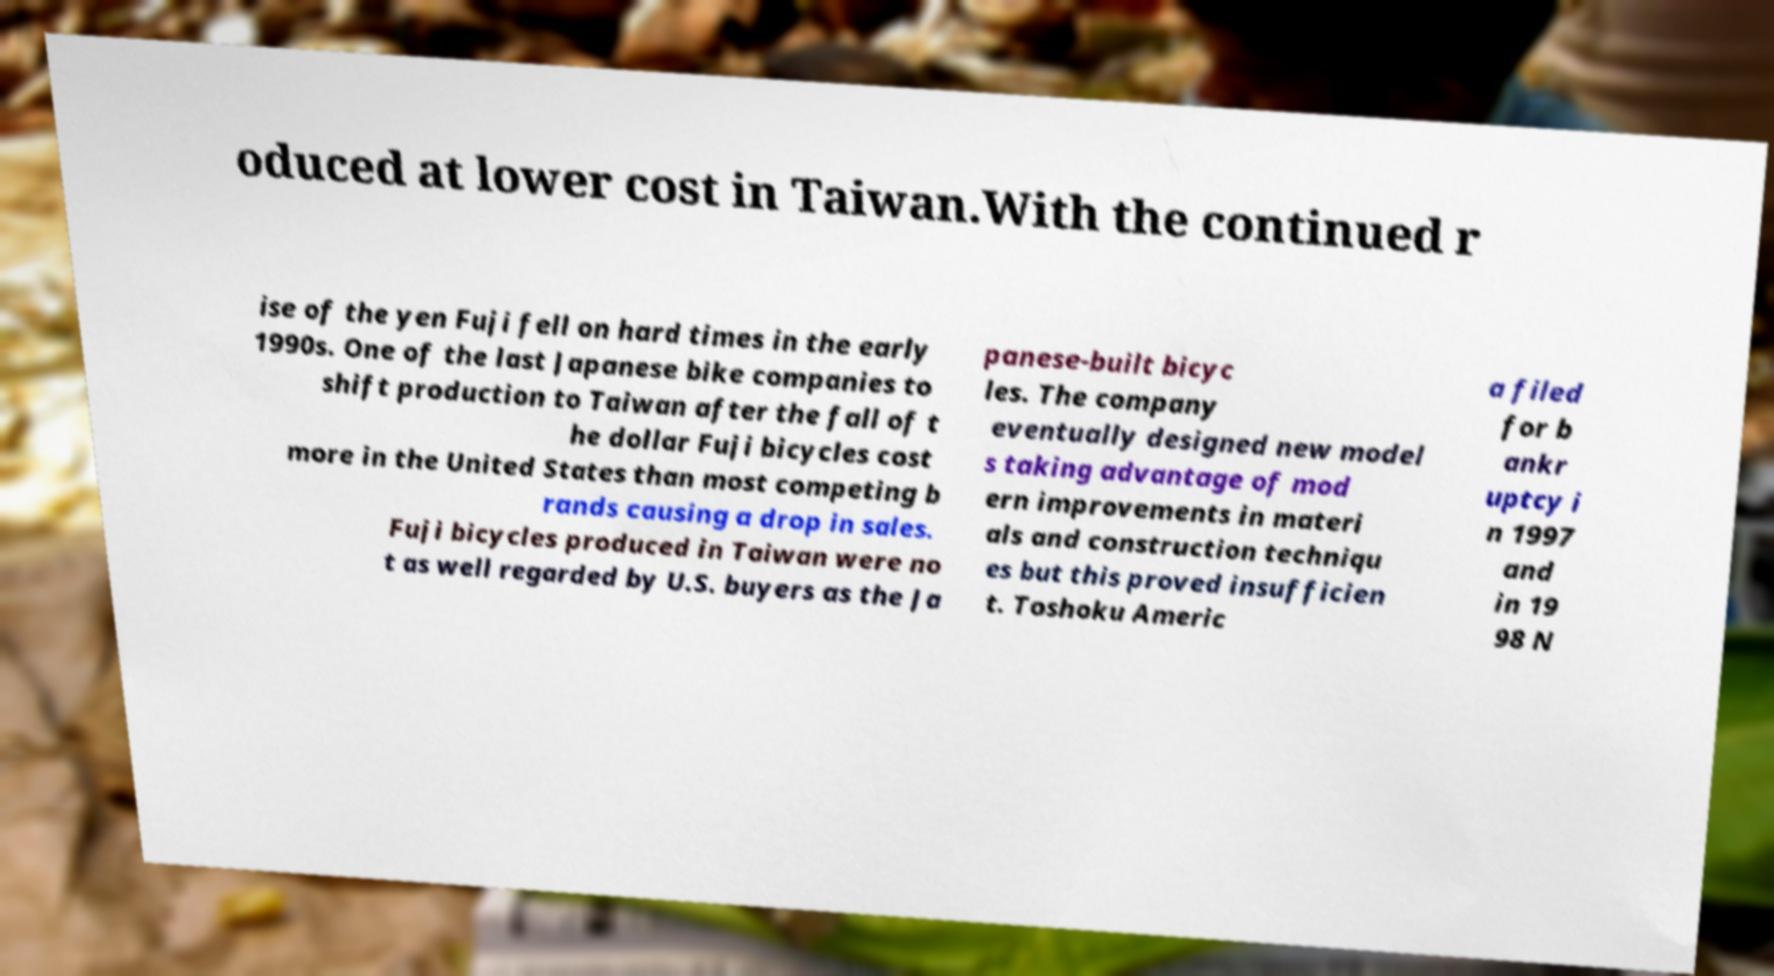For documentation purposes, I need the text within this image transcribed. Could you provide that? oduced at lower cost in Taiwan.With the continued r ise of the yen Fuji fell on hard times in the early 1990s. One of the last Japanese bike companies to shift production to Taiwan after the fall of t he dollar Fuji bicycles cost more in the United States than most competing b rands causing a drop in sales. Fuji bicycles produced in Taiwan were no t as well regarded by U.S. buyers as the Ja panese-built bicyc les. The company eventually designed new model s taking advantage of mod ern improvements in materi als and construction techniqu es but this proved insufficien t. Toshoku Americ a filed for b ankr uptcy i n 1997 and in 19 98 N 